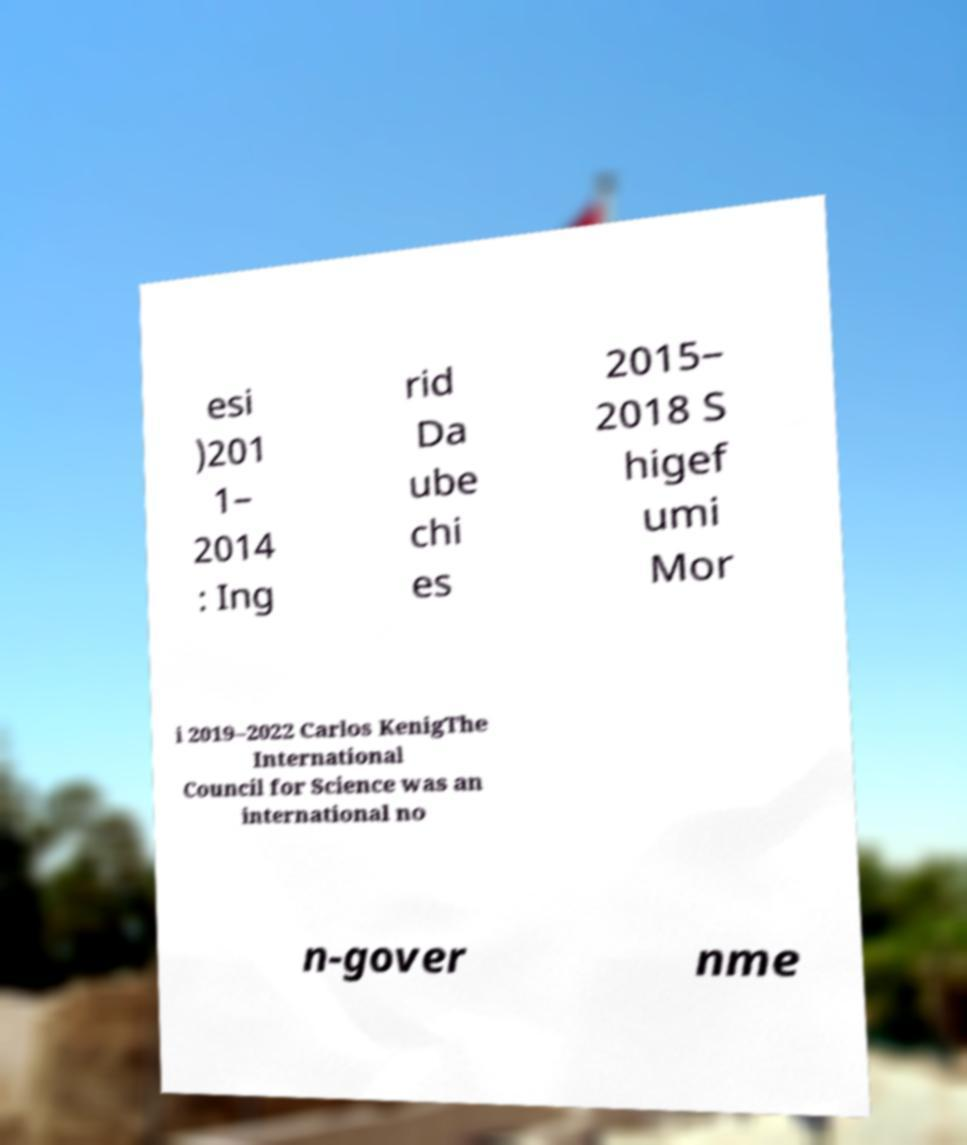For documentation purposes, I need the text within this image transcribed. Could you provide that? esi )201 1– 2014 : Ing rid Da ube chi es 2015– 2018 S higef umi Mor i 2019–2022 Carlos KenigThe International Council for Science was an international no n-gover nme 